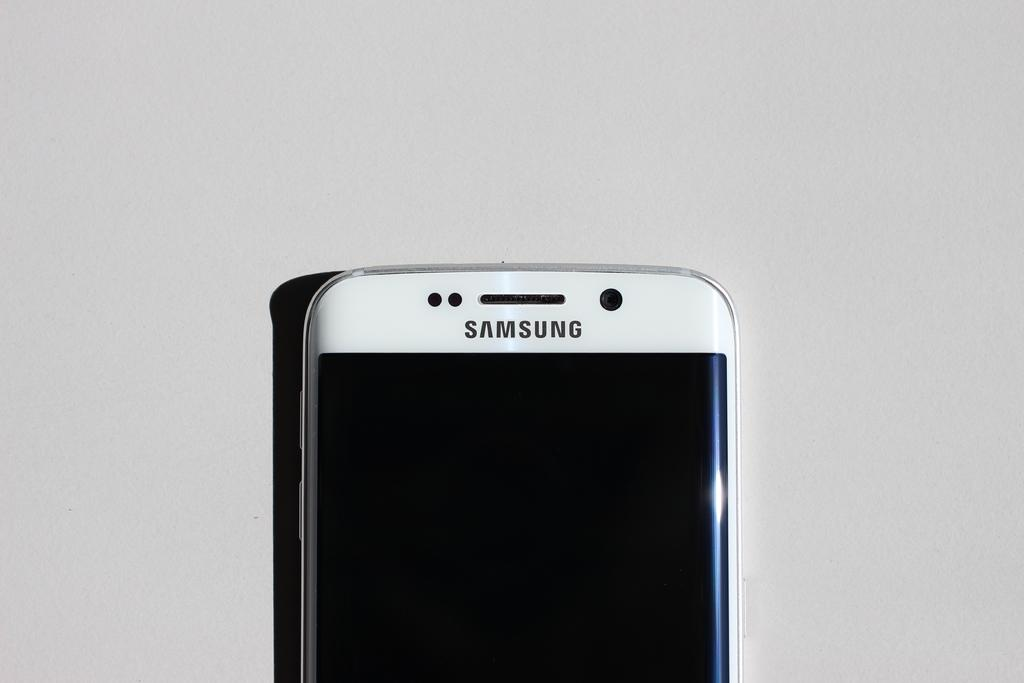Provide a one-sentence caption for the provided image. The top of a white Samsung phone laying on a counter top. 